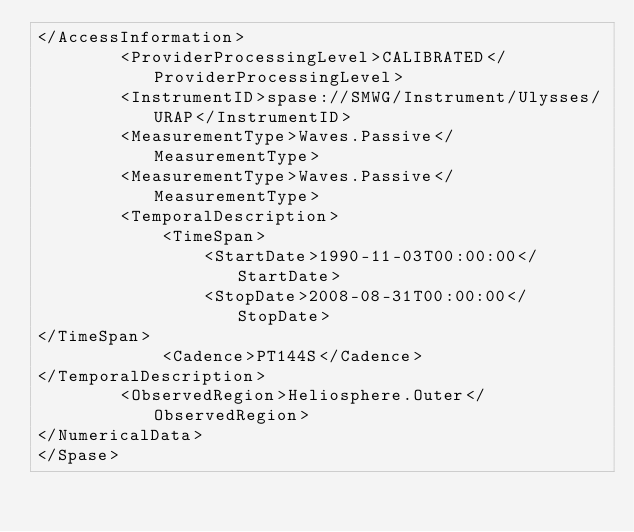Convert code to text. <code><loc_0><loc_0><loc_500><loc_500><_XML_></AccessInformation>
        <ProviderProcessingLevel>CALIBRATED</ProviderProcessingLevel>
        <InstrumentID>spase://SMWG/Instrument/Ulysses/URAP</InstrumentID>
        <MeasurementType>Waves.Passive</MeasurementType>
        <MeasurementType>Waves.Passive</MeasurementType>
        <TemporalDescription>
            <TimeSpan>
                <StartDate>1990-11-03T00:00:00</StartDate>
                <StopDate>2008-08-31T00:00:00</StopDate>
</TimeSpan>
            <Cadence>PT144S</Cadence>
</TemporalDescription>
        <ObservedRegion>Heliosphere.Outer</ObservedRegion>
</NumericalData>
</Spase></code> 